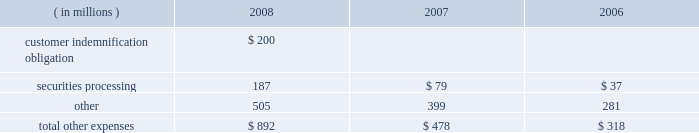Note 21 .
Expenses during the fourth quarter of 2008 , we elected to provide support to certain investment accounts managed by ssga through the purchase of asset- and mortgage-backed securities and a cash infusion , which resulted in a charge of $ 450 million .
Ssga manages certain investment accounts , offered to retirement plans , that allow participants to purchase and redeem units at a constant net asset value regardless of volatility in the underlying value of the assets held by the account .
The accounts enter into contractual arrangements with independent third-party financial institutions that agree to make up any shortfall in the account if all the units are redeemed at the constant net asset value .
The financial institutions have the right , under certain circumstances , to terminate this guarantee with respect to future investments in the account .
During 2008 , the liquidity and pricing issues in the fixed-income markets adversely affected the market value of the securities in these accounts to the point that the third-party guarantors considered terminating their financial guarantees with the accounts .
Although we were not statutorily or contractually obligated to do so , we elected to purchase approximately $ 2.49 billion of asset- and mortgage-backed securities from these accounts that had been identified as presenting increased risk in the current market environment and to contribute an aggregate of $ 450 million to the accounts to improve the ratio of the market value of the accounts 2019 portfolio holdings to the book value of the accounts .
We have no ongoing commitment or intent to provide support to these accounts .
The securities are carried in investment securities available for sale in our consolidated statement of condition .
The components of other expenses were as follows for the years ended december 31: .
In september and october 2008 , lehman brothers holdings inc. , or lehman brothers , and certain of its affiliates filed for bankruptcy or other insolvency proceedings .
While we had no unsecured financial exposure to lehman brothers or its affiliates , we indemnified certain customers in connection with these and other collateralized repurchase agreements with lehman brothers entities .
In the then current market environment , the market value of the underlying collateral had declined .
During the third quarter of 2008 , to the extent these declines resulted in collateral value falling below the indemnification obligation , we recorded a reserve to provide for our estimated net exposure .
The reserve , which totaled $ 200 million , was based on the cost of satisfying the indemnification obligation net of the fair value of the collateral , which we purchased during the fourth quarter of 2008 .
The collateral , composed of commercial real estate loans which are discussed in note 5 , is recorded in loans and leases in our consolidated statement of condition. .
What percent did securites processing expenses increase between 2006 and 2008? 
Computations: ((187 - 37) / 37)
Answer: 4.05405. Note 21 .
Expenses during the fourth quarter of 2008 , we elected to provide support to certain investment accounts managed by ssga through the purchase of asset- and mortgage-backed securities and a cash infusion , which resulted in a charge of $ 450 million .
Ssga manages certain investment accounts , offered to retirement plans , that allow participants to purchase and redeem units at a constant net asset value regardless of volatility in the underlying value of the assets held by the account .
The accounts enter into contractual arrangements with independent third-party financial institutions that agree to make up any shortfall in the account if all the units are redeemed at the constant net asset value .
The financial institutions have the right , under certain circumstances , to terminate this guarantee with respect to future investments in the account .
During 2008 , the liquidity and pricing issues in the fixed-income markets adversely affected the market value of the securities in these accounts to the point that the third-party guarantors considered terminating their financial guarantees with the accounts .
Although we were not statutorily or contractually obligated to do so , we elected to purchase approximately $ 2.49 billion of asset- and mortgage-backed securities from these accounts that had been identified as presenting increased risk in the current market environment and to contribute an aggregate of $ 450 million to the accounts to improve the ratio of the market value of the accounts 2019 portfolio holdings to the book value of the accounts .
We have no ongoing commitment or intent to provide support to these accounts .
The securities are carried in investment securities available for sale in our consolidated statement of condition .
The components of other expenses were as follows for the years ended december 31: .
In september and october 2008 , lehman brothers holdings inc. , or lehman brothers , and certain of its affiliates filed for bankruptcy or other insolvency proceedings .
While we had no unsecured financial exposure to lehman brothers or its affiliates , we indemnified certain customers in connection with these and other collateralized repurchase agreements with lehman brothers entities .
In the then current market environment , the market value of the underlying collateral had declined .
During the third quarter of 2008 , to the extent these declines resulted in collateral value falling below the indemnification obligation , we recorded a reserve to provide for our estimated net exposure .
The reserve , which totaled $ 200 million , was based on the cost of satisfying the indemnification obligation net of the fair value of the collateral , which we purchased during the fourth quarter of 2008 .
The collateral , composed of commercial real estate loans which are discussed in note 5 , is recorded in loans and leases in our consolidated statement of condition. .
What portion of the total other expenses is related to securities processing in 2007? 
Computations: (79 / 478)
Answer: 0.16527. 